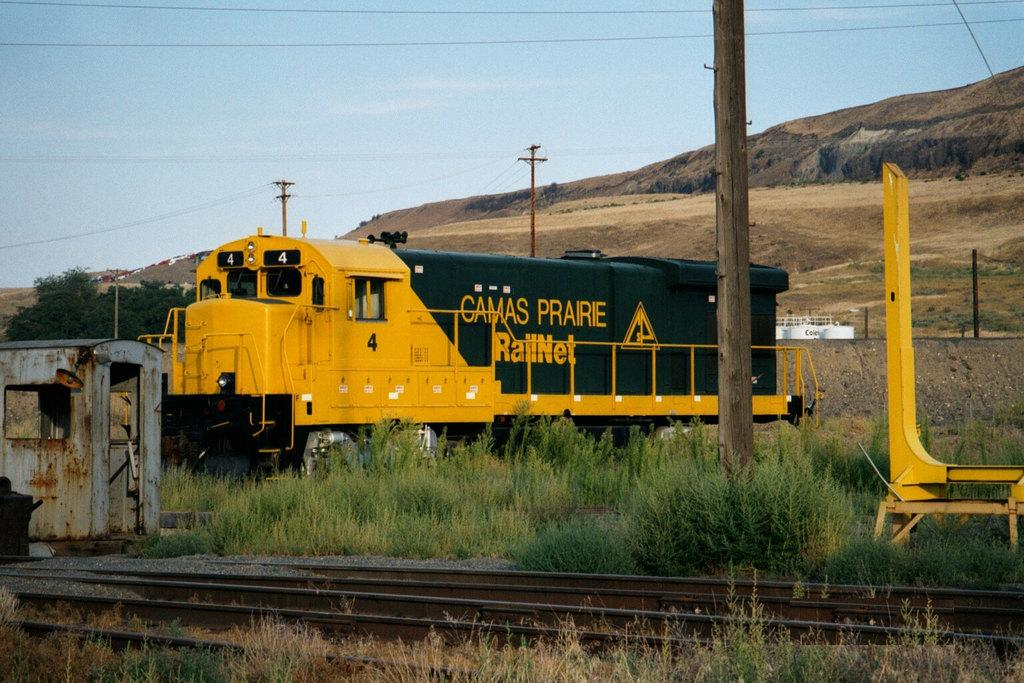<image>
Summarize the visual content of the image. the word camas on the side of a train 